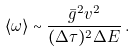<formula> <loc_0><loc_0><loc_500><loc_500>\langle \omega \rangle \sim \frac { \bar { g } ^ { 2 } v ^ { 2 } } { ( \Delta \tau ) ^ { 2 } \Delta E } \, .</formula> 